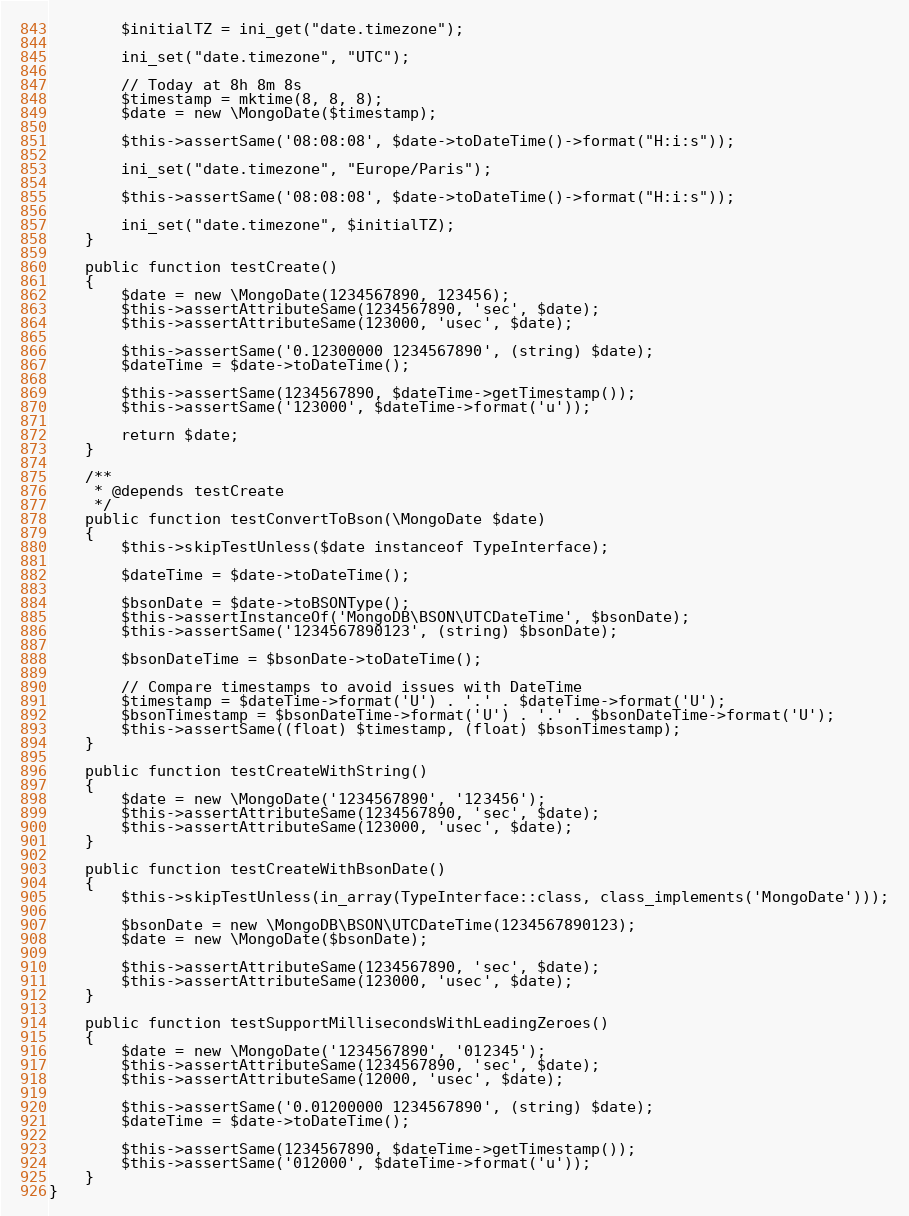Convert code to text. <code><loc_0><loc_0><loc_500><loc_500><_PHP_>        $initialTZ = ini_get("date.timezone");

        ini_set("date.timezone", "UTC");

        // Today at 8h 8m 8s
        $timestamp = mktime(8, 8, 8);
        $date = new \MongoDate($timestamp);

        $this->assertSame('08:08:08', $date->toDateTime()->format("H:i:s"));

        ini_set("date.timezone", "Europe/Paris");

        $this->assertSame('08:08:08', $date->toDateTime()->format("H:i:s"));

        ini_set("date.timezone", $initialTZ);
    }

    public function testCreate()
    {
        $date = new \MongoDate(1234567890, 123456);
        $this->assertAttributeSame(1234567890, 'sec', $date);
        $this->assertAttributeSame(123000, 'usec', $date);

        $this->assertSame('0.12300000 1234567890', (string) $date);
        $dateTime = $date->toDateTime();

        $this->assertSame(1234567890, $dateTime->getTimestamp());
        $this->assertSame('123000', $dateTime->format('u'));

        return $date;
    }

    /**
     * @depends testCreate
     */
    public function testConvertToBson(\MongoDate $date)
    {
        $this->skipTestUnless($date instanceof TypeInterface);

        $dateTime = $date->toDateTime();

        $bsonDate = $date->toBSONType();
        $this->assertInstanceOf('MongoDB\BSON\UTCDateTime', $bsonDate);
        $this->assertSame('1234567890123', (string) $bsonDate);

        $bsonDateTime = $bsonDate->toDateTime();

        // Compare timestamps to avoid issues with DateTime
        $timestamp = $dateTime->format('U') . '.' . $dateTime->format('U');
        $bsonTimestamp = $bsonDateTime->format('U') . '.' . $bsonDateTime->format('U');
        $this->assertSame((float) $timestamp, (float) $bsonTimestamp);
    }

    public function testCreateWithString()
    {
        $date = new \MongoDate('1234567890', '123456');
        $this->assertAttributeSame(1234567890, 'sec', $date);
        $this->assertAttributeSame(123000, 'usec', $date);
    }

    public function testCreateWithBsonDate()
    {
        $this->skipTestUnless(in_array(TypeInterface::class, class_implements('MongoDate')));

        $bsonDate = new \MongoDB\BSON\UTCDateTime(1234567890123);
        $date = new \MongoDate($bsonDate);

        $this->assertAttributeSame(1234567890, 'sec', $date);
        $this->assertAttributeSame(123000, 'usec', $date);
    }

    public function testSupportMillisecondsWithLeadingZeroes()
    {
        $date = new \MongoDate('1234567890', '012345');
        $this->assertAttributeSame(1234567890, 'sec', $date);
        $this->assertAttributeSame(12000, 'usec', $date);

        $this->assertSame('0.01200000 1234567890', (string) $date);
        $dateTime = $date->toDateTime();

        $this->assertSame(1234567890, $dateTime->getTimestamp());
        $this->assertSame('012000', $dateTime->format('u'));
    }
}
</code> 